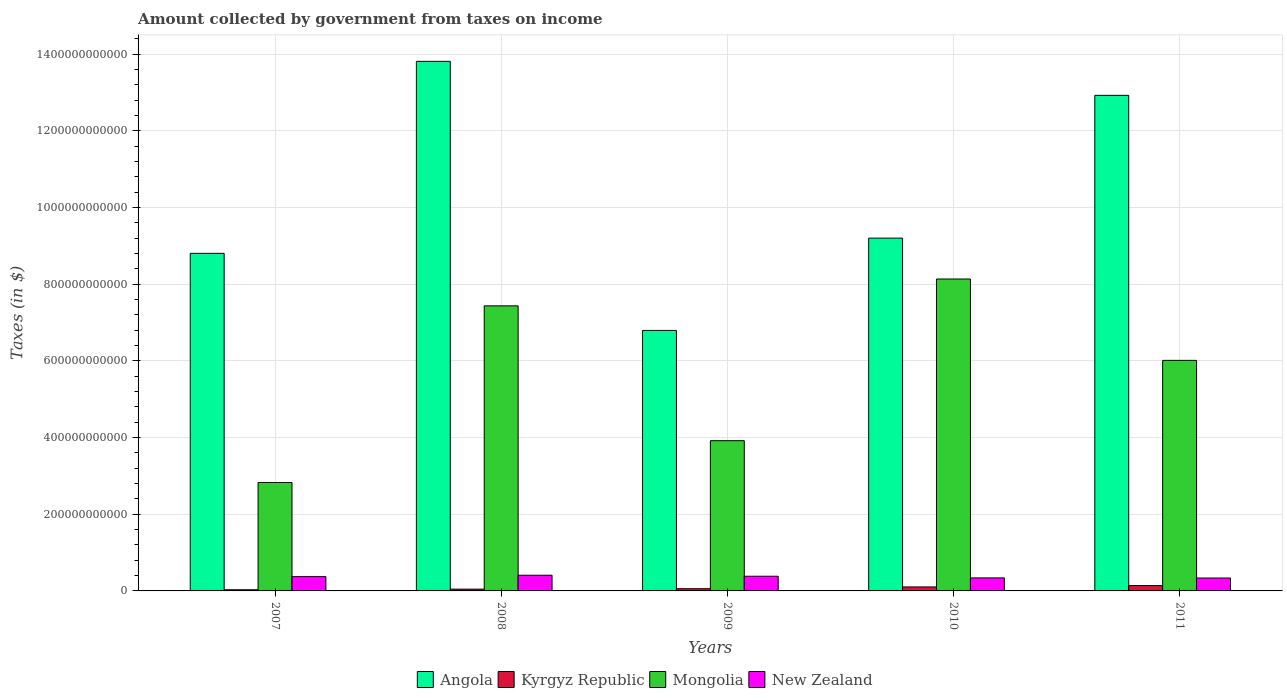How many different coloured bars are there?
Offer a terse response. 4. Are the number of bars per tick equal to the number of legend labels?
Make the answer very short. Yes. How many bars are there on the 2nd tick from the right?
Your answer should be compact. 4. What is the label of the 5th group of bars from the left?
Make the answer very short. 2011. What is the amount collected by government from taxes on income in Kyrgyz Republic in 2008?
Provide a short and direct response. 4.61e+09. Across all years, what is the maximum amount collected by government from taxes on income in New Zealand?
Your answer should be compact. 4.09e+1. Across all years, what is the minimum amount collected by government from taxes on income in Mongolia?
Provide a succinct answer. 2.83e+11. In which year was the amount collected by government from taxes on income in Kyrgyz Republic maximum?
Provide a short and direct response. 2011. In which year was the amount collected by government from taxes on income in Angola minimum?
Make the answer very short. 2009. What is the total amount collected by government from taxes on income in New Zealand in the graph?
Provide a short and direct response. 1.84e+11. What is the difference between the amount collected by government from taxes on income in Angola in 2007 and that in 2011?
Give a very brief answer. -4.12e+11. What is the difference between the amount collected by government from taxes on income in Kyrgyz Republic in 2011 and the amount collected by government from taxes on income in Mongolia in 2008?
Offer a terse response. -7.30e+11. What is the average amount collected by government from taxes on income in Angola per year?
Keep it short and to the point. 1.03e+12. In the year 2008, what is the difference between the amount collected by government from taxes on income in Mongolia and amount collected by government from taxes on income in New Zealand?
Offer a very short reply. 7.03e+11. In how many years, is the amount collected by government from taxes on income in New Zealand greater than 960000000000 $?
Your response must be concise. 0. What is the ratio of the amount collected by government from taxes on income in Mongolia in 2007 to that in 2010?
Provide a short and direct response. 0.35. Is the amount collected by government from taxes on income in Angola in 2007 less than that in 2008?
Your response must be concise. Yes. What is the difference between the highest and the second highest amount collected by government from taxes on income in New Zealand?
Your response must be concise. 2.57e+09. What is the difference between the highest and the lowest amount collected by government from taxes on income in New Zealand?
Give a very brief answer. 7.19e+09. Is it the case that in every year, the sum of the amount collected by government from taxes on income in Angola and amount collected by government from taxes on income in Kyrgyz Republic is greater than the sum of amount collected by government from taxes on income in Mongolia and amount collected by government from taxes on income in New Zealand?
Offer a very short reply. Yes. What does the 1st bar from the left in 2010 represents?
Make the answer very short. Angola. What does the 3rd bar from the right in 2007 represents?
Offer a very short reply. Kyrgyz Republic. Is it the case that in every year, the sum of the amount collected by government from taxes on income in Kyrgyz Republic and amount collected by government from taxes on income in Mongolia is greater than the amount collected by government from taxes on income in New Zealand?
Your answer should be very brief. Yes. Are all the bars in the graph horizontal?
Give a very brief answer. No. How many years are there in the graph?
Make the answer very short. 5. What is the difference between two consecutive major ticks on the Y-axis?
Provide a short and direct response. 2.00e+11. Are the values on the major ticks of Y-axis written in scientific E-notation?
Your answer should be very brief. No. Does the graph contain grids?
Your answer should be very brief. Yes. How many legend labels are there?
Your response must be concise. 4. What is the title of the graph?
Make the answer very short. Amount collected by government from taxes on income. What is the label or title of the Y-axis?
Keep it short and to the point. Taxes (in $). What is the Taxes (in $) of Angola in 2007?
Offer a very short reply. 8.81e+11. What is the Taxes (in $) in Kyrgyz Republic in 2007?
Keep it short and to the point. 3.04e+09. What is the Taxes (in $) of Mongolia in 2007?
Your response must be concise. 2.83e+11. What is the Taxes (in $) of New Zealand in 2007?
Keep it short and to the point. 3.73e+1. What is the Taxes (in $) in Angola in 2008?
Make the answer very short. 1.38e+12. What is the Taxes (in $) in Kyrgyz Republic in 2008?
Offer a very short reply. 4.61e+09. What is the Taxes (in $) in Mongolia in 2008?
Provide a succinct answer. 7.44e+11. What is the Taxes (in $) in New Zealand in 2008?
Make the answer very short. 4.09e+1. What is the Taxes (in $) in Angola in 2009?
Your answer should be compact. 6.80e+11. What is the Taxes (in $) in Kyrgyz Republic in 2009?
Keep it short and to the point. 5.75e+09. What is the Taxes (in $) in Mongolia in 2009?
Offer a very short reply. 3.92e+11. What is the Taxes (in $) in New Zealand in 2009?
Your answer should be very brief. 3.83e+1. What is the Taxes (in $) of Angola in 2010?
Your answer should be compact. 9.20e+11. What is the Taxes (in $) in Kyrgyz Republic in 2010?
Make the answer very short. 1.04e+1. What is the Taxes (in $) of Mongolia in 2010?
Ensure brevity in your answer.  8.14e+11. What is the Taxes (in $) of New Zealand in 2010?
Your response must be concise. 3.40e+1. What is the Taxes (in $) in Angola in 2011?
Offer a very short reply. 1.29e+12. What is the Taxes (in $) in Kyrgyz Republic in 2011?
Ensure brevity in your answer.  1.40e+1. What is the Taxes (in $) in Mongolia in 2011?
Your response must be concise. 6.01e+11. What is the Taxes (in $) of New Zealand in 2011?
Your answer should be very brief. 3.37e+1. Across all years, what is the maximum Taxes (in $) in Angola?
Offer a terse response. 1.38e+12. Across all years, what is the maximum Taxes (in $) of Kyrgyz Republic?
Offer a very short reply. 1.40e+1. Across all years, what is the maximum Taxes (in $) in Mongolia?
Your response must be concise. 8.14e+11. Across all years, what is the maximum Taxes (in $) in New Zealand?
Your response must be concise. 4.09e+1. Across all years, what is the minimum Taxes (in $) in Angola?
Offer a terse response. 6.80e+11. Across all years, what is the minimum Taxes (in $) of Kyrgyz Republic?
Ensure brevity in your answer.  3.04e+09. Across all years, what is the minimum Taxes (in $) of Mongolia?
Ensure brevity in your answer.  2.83e+11. Across all years, what is the minimum Taxes (in $) of New Zealand?
Provide a short and direct response. 3.37e+1. What is the total Taxes (in $) of Angola in the graph?
Offer a very short reply. 5.16e+12. What is the total Taxes (in $) in Kyrgyz Republic in the graph?
Keep it short and to the point. 3.78e+1. What is the total Taxes (in $) in Mongolia in the graph?
Offer a terse response. 2.83e+12. What is the total Taxes (in $) of New Zealand in the graph?
Make the answer very short. 1.84e+11. What is the difference between the Taxes (in $) of Angola in 2007 and that in 2008?
Offer a terse response. -5.01e+11. What is the difference between the Taxes (in $) of Kyrgyz Republic in 2007 and that in 2008?
Keep it short and to the point. -1.57e+09. What is the difference between the Taxes (in $) of Mongolia in 2007 and that in 2008?
Provide a succinct answer. -4.61e+11. What is the difference between the Taxes (in $) in New Zealand in 2007 and that in 2008?
Make the answer very short. -3.57e+09. What is the difference between the Taxes (in $) of Angola in 2007 and that in 2009?
Give a very brief answer. 2.01e+11. What is the difference between the Taxes (in $) in Kyrgyz Republic in 2007 and that in 2009?
Your answer should be very brief. -2.71e+09. What is the difference between the Taxes (in $) of Mongolia in 2007 and that in 2009?
Your response must be concise. -1.09e+11. What is the difference between the Taxes (in $) in New Zealand in 2007 and that in 2009?
Your answer should be very brief. -9.92e+08. What is the difference between the Taxes (in $) in Angola in 2007 and that in 2010?
Your answer should be compact. -3.97e+1. What is the difference between the Taxes (in $) in Kyrgyz Republic in 2007 and that in 2010?
Provide a short and direct response. -7.35e+09. What is the difference between the Taxes (in $) in Mongolia in 2007 and that in 2010?
Your answer should be very brief. -5.31e+11. What is the difference between the Taxes (in $) of New Zealand in 2007 and that in 2010?
Your answer should be very brief. 3.33e+09. What is the difference between the Taxes (in $) in Angola in 2007 and that in 2011?
Your response must be concise. -4.12e+11. What is the difference between the Taxes (in $) in Kyrgyz Republic in 2007 and that in 2011?
Make the answer very short. -1.09e+1. What is the difference between the Taxes (in $) of Mongolia in 2007 and that in 2011?
Your answer should be compact. -3.19e+11. What is the difference between the Taxes (in $) of New Zealand in 2007 and that in 2011?
Provide a short and direct response. 3.62e+09. What is the difference between the Taxes (in $) in Angola in 2008 and that in 2009?
Your answer should be very brief. 7.02e+11. What is the difference between the Taxes (in $) of Kyrgyz Republic in 2008 and that in 2009?
Your answer should be compact. -1.14e+09. What is the difference between the Taxes (in $) of Mongolia in 2008 and that in 2009?
Make the answer very short. 3.52e+11. What is the difference between the Taxes (in $) in New Zealand in 2008 and that in 2009?
Give a very brief answer. 2.57e+09. What is the difference between the Taxes (in $) of Angola in 2008 and that in 2010?
Your answer should be compact. 4.61e+11. What is the difference between the Taxes (in $) of Kyrgyz Republic in 2008 and that in 2010?
Your response must be concise. -5.77e+09. What is the difference between the Taxes (in $) of Mongolia in 2008 and that in 2010?
Offer a very short reply. -7.00e+1. What is the difference between the Taxes (in $) of New Zealand in 2008 and that in 2010?
Keep it short and to the point. 6.90e+09. What is the difference between the Taxes (in $) in Angola in 2008 and that in 2011?
Your answer should be very brief. 8.87e+1. What is the difference between the Taxes (in $) in Kyrgyz Republic in 2008 and that in 2011?
Offer a very short reply. -9.36e+09. What is the difference between the Taxes (in $) of Mongolia in 2008 and that in 2011?
Make the answer very short. 1.42e+11. What is the difference between the Taxes (in $) in New Zealand in 2008 and that in 2011?
Your answer should be compact. 7.19e+09. What is the difference between the Taxes (in $) in Angola in 2009 and that in 2010?
Your answer should be compact. -2.41e+11. What is the difference between the Taxes (in $) in Kyrgyz Republic in 2009 and that in 2010?
Provide a succinct answer. -4.63e+09. What is the difference between the Taxes (in $) of Mongolia in 2009 and that in 2010?
Give a very brief answer. -4.22e+11. What is the difference between the Taxes (in $) of New Zealand in 2009 and that in 2010?
Keep it short and to the point. 4.32e+09. What is the difference between the Taxes (in $) of Angola in 2009 and that in 2011?
Provide a short and direct response. -6.13e+11. What is the difference between the Taxes (in $) in Kyrgyz Republic in 2009 and that in 2011?
Your answer should be very brief. -8.23e+09. What is the difference between the Taxes (in $) in Mongolia in 2009 and that in 2011?
Keep it short and to the point. -2.10e+11. What is the difference between the Taxes (in $) of New Zealand in 2009 and that in 2011?
Your answer should be compact. 4.61e+09. What is the difference between the Taxes (in $) of Angola in 2010 and that in 2011?
Offer a very short reply. -3.73e+11. What is the difference between the Taxes (in $) in Kyrgyz Republic in 2010 and that in 2011?
Your response must be concise. -3.59e+09. What is the difference between the Taxes (in $) in Mongolia in 2010 and that in 2011?
Ensure brevity in your answer.  2.12e+11. What is the difference between the Taxes (in $) of New Zealand in 2010 and that in 2011?
Keep it short and to the point. 2.87e+08. What is the difference between the Taxes (in $) in Angola in 2007 and the Taxes (in $) in Kyrgyz Republic in 2008?
Your answer should be very brief. 8.76e+11. What is the difference between the Taxes (in $) of Angola in 2007 and the Taxes (in $) of Mongolia in 2008?
Give a very brief answer. 1.37e+11. What is the difference between the Taxes (in $) of Angola in 2007 and the Taxes (in $) of New Zealand in 2008?
Your answer should be very brief. 8.40e+11. What is the difference between the Taxes (in $) of Kyrgyz Republic in 2007 and the Taxes (in $) of Mongolia in 2008?
Provide a short and direct response. -7.41e+11. What is the difference between the Taxes (in $) in Kyrgyz Republic in 2007 and the Taxes (in $) in New Zealand in 2008?
Offer a very short reply. -3.78e+1. What is the difference between the Taxes (in $) of Mongolia in 2007 and the Taxes (in $) of New Zealand in 2008?
Provide a succinct answer. 2.42e+11. What is the difference between the Taxes (in $) in Angola in 2007 and the Taxes (in $) in Kyrgyz Republic in 2009?
Your answer should be compact. 8.75e+11. What is the difference between the Taxes (in $) of Angola in 2007 and the Taxes (in $) of Mongolia in 2009?
Give a very brief answer. 4.89e+11. What is the difference between the Taxes (in $) of Angola in 2007 and the Taxes (in $) of New Zealand in 2009?
Provide a short and direct response. 8.42e+11. What is the difference between the Taxes (in $) of Kyrgyz Republic in 2007 and the Taxes (in $) of Mongolia in 2009?
Your answer should be very brief. -3.89e+11. What is the difference between the Taxes (in $) in Kyrgyz Republic in 2007 and the Taxes (in $) in New Zealand in 2009?
Ensure brevity in your answer.  -3.53e+1. What is the difference between the Taxes (in $) in Mongolia in 2007 and the Taxes (in $) in New Zealand in 2009?
Make the answer very short. 2.45e+11. What is the difference between the Taxes (in $) of Angola in 2007 and the Taxes (in $) of Kyrgyz Republic in 2010?
Offer a terse response. 8.70e+11. What is the difference between the Taxes (in $) of Angola in 2007 and the Taxes (in $) of Mongolia in 2010?
Provide a succinct answer. 6.70e+1. What is the difference between the Taxes (in $) of Angola in 2007 and the Taxes (in $) of New Zealand in 2010?
Your response must be concise. 8.47e+11. What is the difference between the Taxes (in $) of Kyrgyz Republic in 2007 and the Taxes (in $) of Mongolia in 2010?
Make the answer very short. -8.11e+11. What is the difference between the Taxes (in $) of Kyrgyz Republic in 2007 and the Taxes (in $) of New Zealand in 2010?
Keep it short and to the point. -3.09e+1. What is the difference between the Taxes (in $) of Mongolia in 2007 and the Taxes (in $) of New Zealand in 2010?
Make the answer very short. 2.49e+11. What is the difference between the Taxes (in $) in Angola in 2007 and the Taxes (in $) in Kyrgyz Republic in 2011?
Ensure brevity in your answer.  8.67e+11. What is the difference between the Taxes (in $) in Angola in 2007 and the Taxes (in $) in Mongolia in 2011?
Offer a very short reply. 2.79e+11. What is the difference between the Taxes (in $) of Angola in 2007 and the Taxes (in $) of New Zealand in 2011?
Your response must be concise. 8.47e+11. What is the difference between the Taxes (in $) of Kyrgyz Republic in 2007 and the Taxes (in $) of Mongolia in 2011?
Make the answer very short. -5.98e+11. What is the difference between the Taxes (in $) in Kyrgyz Republic in 2007 and the Taxes (in $) in New Zealand in 2011?
Offer a very short reply. -3.07e+1. What is the difference between the Taxes (in $) in Mongolia in 2007 and the Taxes (in $) in New Zealand in 2011?
Ensure brevity in your answer.  2.49e+11. What is the difference between the Taxes (in $) in Angola in 2008 and the Taxes (in $) in Kyrgyz Republic in 2009?
Ensure brevity in your answer.  1.38e+12. What is the difference between the Taxes (in $) of Angola in 2008 and the Taxes (in $) of Mongolia in 2009?
Provide a short and direct response. 9.90e+11. What is the difference between the Taxes (in $) in Angola in 2008 and the Taxes (in $) in New Zealand in 2009?
Offer a very short reply. 1.34e+12. What is the difference between the Taxes (in $) in Kyrgyz Republic in 2008 and the Taxes (in $) in Mongolia in 2009?
Keep it short and to the point. -3.87e+11. What is the difference between the Taxes (in $) of Kyrgyz Republic in 2008 and the Taxes (in $) of New Zealand in 2009?
Your response must be concise. -3.37e+1. What is the difference between the Taxes (in $) of Mongolia in 2008 and the Taxes (in $) of New Zealand in 2009?
Give a very brief answer. 7.05e+11. What is the difference between the Taxes (in $) of Angola in 2008 and the Taxes (in $) of Kyrgyz Republic in 2010?
Ensure brevity in your answer.  1.37e+12. What is the difference between the Taxes (in $) in Angola in 2008 and the Taxes (in $) in Mongolia in 2010?
Your answer should be very brief. 5.68e+11. What is the difference between the Taxes (in $) in Angola in 2008 and the Taxes (in $) in New Zealand in 2010?
Keep it short and to the point. 1.35e+12. What is the difference between the Taxes (in $) of Kyrgyz Republic in 2008 and the Taxes (in $) of Mongolia in 2010?
Your answer should be very brief. -8.09e+11. What is the difference between the Taxes (in $) of Kyrgyz Republic in 2008 and the Taxes (in $) of New Zealand in 2010?
Your response must be concise. -2.94e+1. What is the difference between the Taxes (in $) of Mongolia in 2008 and the Taxes (in $) of New Zealand in 2010?
Offer a terse response. 7.10e+11. What is the difference between the Taxes (in $) of Angola in 2008 and the Taxes (in $) of Kyrgyz Republic in 2011?
Provide a succinct answer. 1.37e+12. What is the difference between the Taxes (in $) of Angola in 2008 and the Taxes (in $) of Mongolia in 2011?
Your response must be concise. 7.80e+11. What is the difference between the Taxes (in $) of Angola in 2008 and the Taxes (in $) of New Zealand in 2011?
Provide a short and direct response. 1.35e+12. What is the difference between the Taxes (in $) of Kyrgyz Republic in 2008 and the Taxes (in $) of Mongolia in 2011?
Provide a short and direct response. -5.97e+11. What is the difference between the Taxes (in $) of Kyrgyz Republic in 2008 and the Taxes (in $) of New Zealand in 2011?
Keep it short and to the point. -2.91e+1. What is the difference between the Taxes (in $) in Mongolia in 2008 and the Taxes (in $) in New Zealand in 2011?
Your answer should be very brief. 7.10e+11. What is the difference between the Taxes (in $) of Angola in 2009 and the Taxes (in $) of Kyrgyz Republic in 2010?
Your answer should be very brief. 6.69e+11. What is the difference between the Taxes (in $) of Angola in 2009 and the Taxes (in $) of Mongolia in 2010?
Provide a succinct answer. -1.34e+11. What is the difference between the Taxes (in $) in Angola in 2009 and the Taxes (in $) in New Zealand in 2010?
Provide a succinct answer. 6.46e+11. What is the difference between the Taxes (in $) of Kyrgyz Republic in 2009 and the Taxes (in $) of Mongolia in 2010?
Offer a very short reply. -8.08e+11. What is the difference between the Taxes (in $) of Kyrgyz Republic in 2009 and the Taxes (in $) of New Zealand in 2010?
Keep it short and to the point. -2.82e+1. What is the difference between the Taxes (in $) in Mongolia in 2009 and the Taxes (in $) in New Zealand in 2010?
Offer a very short reply. 3.58e+11. What is the difference between the Taxes (in $) of Angola in 2009 and the Taxes (in $) of Kyrgyz Republic in 2011?
Make the answer very short. 6.66e+11. What is the difference between the Taxes (in $) in Angola in 2009 and the Taxes (in $) in Mongolia in 2011?
Provide a short and direct response. 7.81e+1. What is the difference between the Taxes (in $) of Angola in 2009 and the Taxes (in $) of New Zealand in 2011?
Provide a short and direct response. 6.46e+11. What is the difference between the Taxes (in $) in Kyrgyz Republic in 2009 and the Taxes (in $) in Mongolia in 2011?
Keep it short and to the point. -5.96e+11. What is the difference between the Taxes (in $) in Kyrgyz Republic in 2009 and the Taxes (in $) in New Zealand in 2011?
Your answer should be compact. -2.79e+1. What is the difference between the Taxes (in $) of Mongolia in 2009 and the Taxes (in $) of New Zealand in 2011?
Offer a terse response. 3.58e+11. What is the difference between the Taxes (in $) in Angola in 2010 and the Taxes (in $) in Kyrgyz Republic in 2011?
Your answer should be very brief. 9.06e+11. What is the difference between the Taxes (in $) of Angola in 2010 and the Taxes (in $) of Mongolia in 2011?
Your answer should be compact. 3.19e+11. What is the difference between the Taxes (in $) in Angola in 2010 and the Taxes (in $) in New Zealand in 2011?
Your answer should be compact. 8.87e+11. What is the difference between the Taxes (in $) in Kyrgyz Republic in 2010 and the Taxes (in $) in Mongolia in 2011?
Give a very brief answer. -5.91e+11. What is the difference between the Taxes (in $) in Kyrgyz Republic in 2010 and the Taxes (in $) in New Zealand in 2011?
Ensure brevity in your answer.  -2.33e+1. What is the difference between the Taxes (in $) of Mongolia in 2010 and the Taxes (in $) of New Zealand in 2011?
Give a very brief answer. 7.80e+11. What is the average Taxes (in $) of Angola per year?
Provide a succinct answer. 1.03e+12. What is the average Taxes (in $) in Kyrgyz Republic per year?
Make the answer very short. 7.55e+09. What is the average Taxes (in $) in Mongolia per year?
Keep it short and to the point. 5.67e+11. What is the average Taxes (in $) in New Zealand per year?
Provide a short and direct response. 3.68e+1. In the year 2007, what is the difference between the Taxes (in $) in Angola and Taxes (in $) in Kyrgyz Republic?
Ensure brevity in your answer.  8.78e+11. In the year 2007, what is the difference between the Taxes (in $) of Angola and Taxes (in $) of Mongolia?
Offer a very short reply. 5.98e+11. In the year 2007, what is the difference between the Taxes (in $) in Angola and Taxes (in $) in New Zealand?
Your answer should be compact. 8.43e+11. In the year 2007, what is the difference between the Taxes (in $) of Kyrgyz Republic and Taxes (in $) of Mongolia?
Give a very brief answer. -2.80e+11. In the year 2007, what is the difference between the Taxes (in $) of Kyrgyz Republic and Taxes (in $) of New Zealand?
Provide a short and direct response. -3.43e+1. In the year 2007, what is the difference between the Taxes (in $) in Mongolia and Taxes (in $) in New Zealand?
Your answer should be compact. 2.46e+11. In the year 2008, what is the difference between the Taxes (in $) of Angola and Taxes (in $) of Kyrgyz Republic?
Your response must be concise. 1.38e+12. In the year 2008, what is the difference between the Taxes (in $) in Angola and Taxes (in $) in Mongolia?
Provide a succinct answer. 6.38e+11. In the year 2008, what is the difference between the Taxes (in $) in Angola and Taxes (in $) in New Zealand?
Offer a terse response. 1.34e+12. In the year 2008, what is the difference between the Taxes (in $) of Kyrgyz Republic and Taxes (in $) of Mongolia?
Make the answer very short. -7.39e+11. In the year 2008, what is the difference between the Taxes (in $) in Kyrgyz Republic and Taxes (in $) in New Zealand?
Your response must be concise. -3.63e+1. In the year 2008, what is the difference between the Taxes (in $) in Mongolia and Taxes (in $) in New Zealand?
Provide a succinct answer. 7.03e+11. In the year 2009, what is the difference between the Taxes (in $) of Angola and Taxes (in $) of Kyrgyz Republic?
Offer a terse response. 6.74e+11. In the year 2009, what is the difference between the Taxes (in $) of Angola and Taxes (in $) of Mongolia?
Keep it short and to the point. 2.88e+11. In the year 2009, what is the difference between the Taxes (in $) in Angola and Taxes (in $) in New Zealand?
Offer a very short reply. 6.41e+11. In the year 2009, what is the difference between the Taxes (in $) in Kyrgyz Republic and Taxes (in $) in Mongolia?
Provide a succinct answer. -3.86e+11. In the year 2009, what is the difference between the Taxes (in $) of Kyrgyz Republic and Taxes (in $) of New Zealand?
Provide a short and direct response. -3.26e+1. In the year 2009, what is the difference between the Taxes (in $) in Mongolia and Taxes (in $) in New Zealand?
Your answer should be compact. 3.54e+11. In the year 2010, what is the difference between the Taxes (in $) of Angola and Taxes (in $) of Kyrgyz Republic?
Give a very brief answer. 9.10e+11. In the year 2010, what is the difference between the Taxes (in $) of Angola and Taxes (in $) of Mongolia?
Provide a short and direct response. 1.07e+11. In the year 2010, what is the difference between the Taxes (in $) of Angola and Taxes (in $) of New Zealand?
Make the answer very short. 8.86e+11. In the year 2010, what is the difference between the Taxes (in $) in Kyrgyz Republic and Taxes (in $) in Mongolia?
Your response must be concise. -8.03e+11. In the year 2010, what is the difference between the Taxes (in $) of Kyrgyz Republic and Taxes (in $) of New Zealand?
Your answer should be very brief. -2.36e+1. In the year 2010, what is the difference between the Taxes (in $) of Mongolia and Taxes (in $) of New Zealand?
Your answer should be very brief. 7.80e+11. In the year 2011, what is the difference between the Taxes (in $) of Angola and Taxes (in $) of Kyrgyz Republic?
Your answer should be very brief. 1.28e+12. In the year 2011, what is the difference between the Taxes (in $) in Angola and Taxes (in $) in Mongolia?
Provide a short and direct response. 6.91e+11. In the year 2011, what is the difference between the Taxes (in $) of Angola and Taxes (in $) of New Zealand?
Give a very brief answer. 1.26e+12. In the year 2011, what is the difference between the Taxes (in $) of Kyrgyz Republic and Taxes (in $) of Mongolia?
Your response must be concise. -5.88e+11. In the year 2011, what is the difference between the Taxes (in $) of Kyrgyz Republic and Taxes (in $) of New Zealand?
Give a very brief answer. -1.97e+1. In the year 2011, what is the difference between the Taxes (in $) of Mongolia and Taxes (in $) of New Zealand?
Offer a terse response. 5.68e+11. What is the ratio of the Taxes (in $) in Angola in 2007 to that in 2008?
Your answer should be compact. 0.64. What is the ratio of the Taxes (in $) in Kyrgyz Republic in 2007 to that in 2008?
Offer a very short reply. 0.66. What is the ratio of the Taxes (in $) of Mongolia in 2007 to that in 2008?
Provide a short and direct response. 0.38. What is the ratio of the Taxes (in $) in New Zealand in 2007 to that in 2008?
Provide a short and direct response. 0.91. What is the ratio of the Taxes (in $) of Angola in 2007 to that in 2009?
Your response must be concise. 1.3. What is the ratio of the Taxes (in $) in Kyrgyz Republic in 2007 to that in 2009?
Keep it short and to the point. 0.53. What is the ratio of the Taxes (in $) in Mongolia in 2007 to that in 2009?
Give a very brief answer. 0.72. What is the ratio of the Taxes (in $) of New Zealand in 2007 to that in 2009?
Your response must be concise. 0.97. What is the ratio of the Taxes (in $) in Angola in 2007 to that in 2010?
Ensure brevity in your answer.  0.96. What is the ratio of the Taxes (in $) of Kyrgyz Republic in 2007 to that in 2010?
Provide a short and direct response. 0.29. What is the ratio of the Taxes (in $) of Mongolia in 2007 to that in 2010?
Make the answer very short. 0.35. What is the ratio of the Taxes (in $) of New Zealand in 2007 to that in 2010?
Offer a very short reply. 1.1. What is the ratio of the Taxes (in $) in Angola in 2007 to that in 2011?
Ensure brevity in your answer.  0.68. What is the ratio of the Taxes (in $) of Kyrgyz Republic in 2007 to that in 2011?
Make the answer very short. 0.22. What is the ratio of the Taxes (in $) in Mongolia in 2007 to that in 2011?
Provide a succinct answer. 0.47. What is the ratio of the Taxes (in $) of New Zealand in 2007 to that in 2011?
Provide a succinct answer. 1.11. What is the ratio of the Taxes (in $) in Angola in 2008 to that in 2009?
Give a very brief answer. 2.03. What is the ratio of the Taxes (in $) of Kyrgyz Republic in 2008 to that in 2009?
Your answer should be very brief. 0.8. What is the ratio of the Taxes (in $) of Mongolia in 2008 to that in 2009?
Keep it short and to the point. 1.9. What is the ratio of the Taxes (in $) in New Zealand in 2008 to that in 2009?
Provide a succinct answer. 1.07. What is the ratio of the Taxes (in $) of Angola in 2008 to that in 2010?
Offer a terse response. 1.5. What is the ratio of the Taxes (in $) in Kyrgyz Republic in 2008 to that in 2010?
Give a very brief answer. 0.44. What is the ratio of the Taxes (in $) in Mongolia in 2008 to that in 2010?
Ensure brevity in your answer.  0.91. What is the ratio of the Taxes (in $) of New Zealand in 2008 to that in 2010?
Keep it short and to the point. 1.2. What is the ratio of the Taxes (in $) of Angola in 2008 to that in 2011?
Offer a terse response. 1.07. What is the ratio of the Taxes (in $) in Kyrgyz Republic in 2008 to that in 2011?
Make the answer very short. 0.33. What is the ratio of the Taxes (in $) of Mongolia in 2008 to that in 2011?
Your answer should be very brief. 1.24. What is the ratio of the Taxes (in $) of New Zealand in 2008 to that in 2011?
Your response must be concise. 1.21. What is the ratio of the Taxes (in $) of Angola in 2009 to that in 2010?
Your answer should be very brief. 0.74. What is the ratio of the Taxes (in $) in Kyrgyz Republic in 2009 to that in 2010?
Provide a short and direct response. 0.55. What is the ratio of the Taxes (in $) in Mongolia in 2009 to that in 2010?
Provide a succinct answer. 0.48. What is the ratio of the Taxes (in $) in New Zealand in 2009 to that in 2010?
Make the answer very short. 1.13. What is the ratio of the Taxes (in $) of Angola in 2009 to that in 2011?
Keep it short and to the point. 0.53. What is the ratio of the Taxes (in $) in Kyrgyz Republic in 2009 to that in 2011?
Offer a very short reply. 0.41. What is the ratio of the Taxes (in $) in Mongolia in 2009 to that in 2011?
Provide a succinct answer. 0.65. What is the ratio of the Taxes (in $) in New Zealand in 2009 to that in 2011?
Make the answer very short. 1.14. What is the ratio of the Taxes (in $) of Angola in 2010 to that in 2011?
Keep it short and to the point. 0.71. What is the ratio of the Taxes (in $) in Kyrgyz Republic in 2010 to that in 2011?
Make the answer very short. 0.74. What is the ratio of the Taxes (in $) in Mongolia in 2010 to that in 2011?
Ensure brevity in your answer.  1.35. What is the ratio of the Taxes (in $) of New Zealand in 2010 to that in 2011?
Your answer should be very brief. 1.01. What is the difference between the highest and the second highest Taxes (in $) in Angola?
Offer a very short reply. 8.87e+1. What is the difference between the highest and the second highest Taxes (in $) of Kyrgyz Republic?
Provide a succinct answer. 3.59e+09. What is the difference between the highest and the second highest Taxes (in $) of Mongolia?
Provide a short and direct response. 7.00e+1. What is the difference between the highest and the second highest Taxes (in $) in New Zealand?
Your answer should be very brief. 2.57e+09. What is the difference between the highest and the lowest Taxes (in $) in Angola?
Give a very brief answer. 7.02e+11. What is the difference between the highest and the lowest Taxes (in $) in Kyrgyz Republic?
Keep it short and to the point. 1.09e+1. What is the difference between the highest and the lowest Taxes (in $) of Mongolia?
Your response must be concise. 5.31e+11. What is the difference between the highest and the lowest Taxes (in $) of New Zealand?
Ensure brevity in your answer.  7.19e+09. 